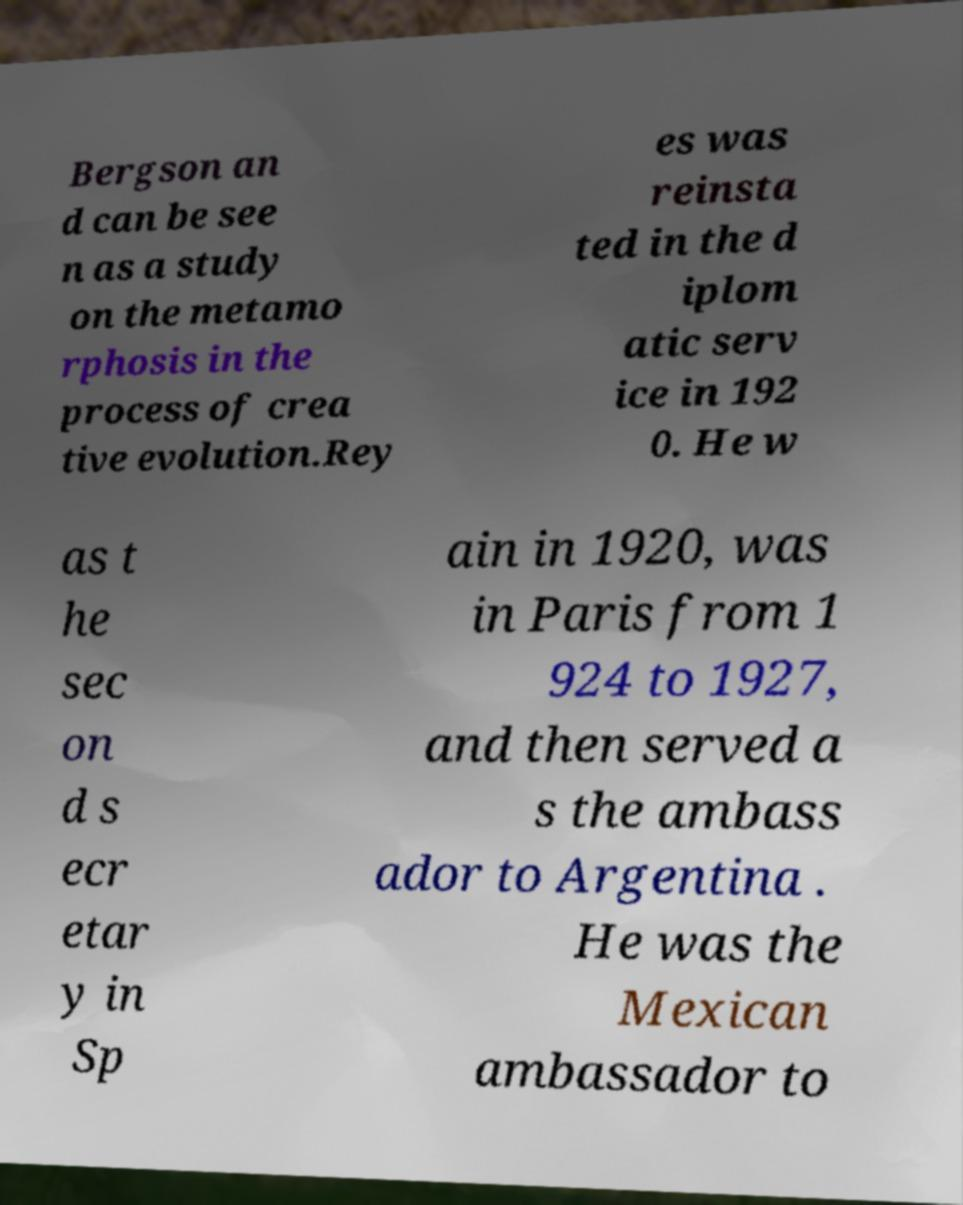Could you assist in decoding the text presented in this image and type it out clearly? Bergson an d can be see n as a study on the metamo rphosis in the process of crea tive evolution.Rey es was reinsta ted in the d iplom atic serv ice in 192 0. He w as t he sec on d s ecr etar y in Sp ain in 1920, was in Paris from 1 924 to 1927, and then served a s the ambass ador to Argentina . He was the Mexican ambassador to 